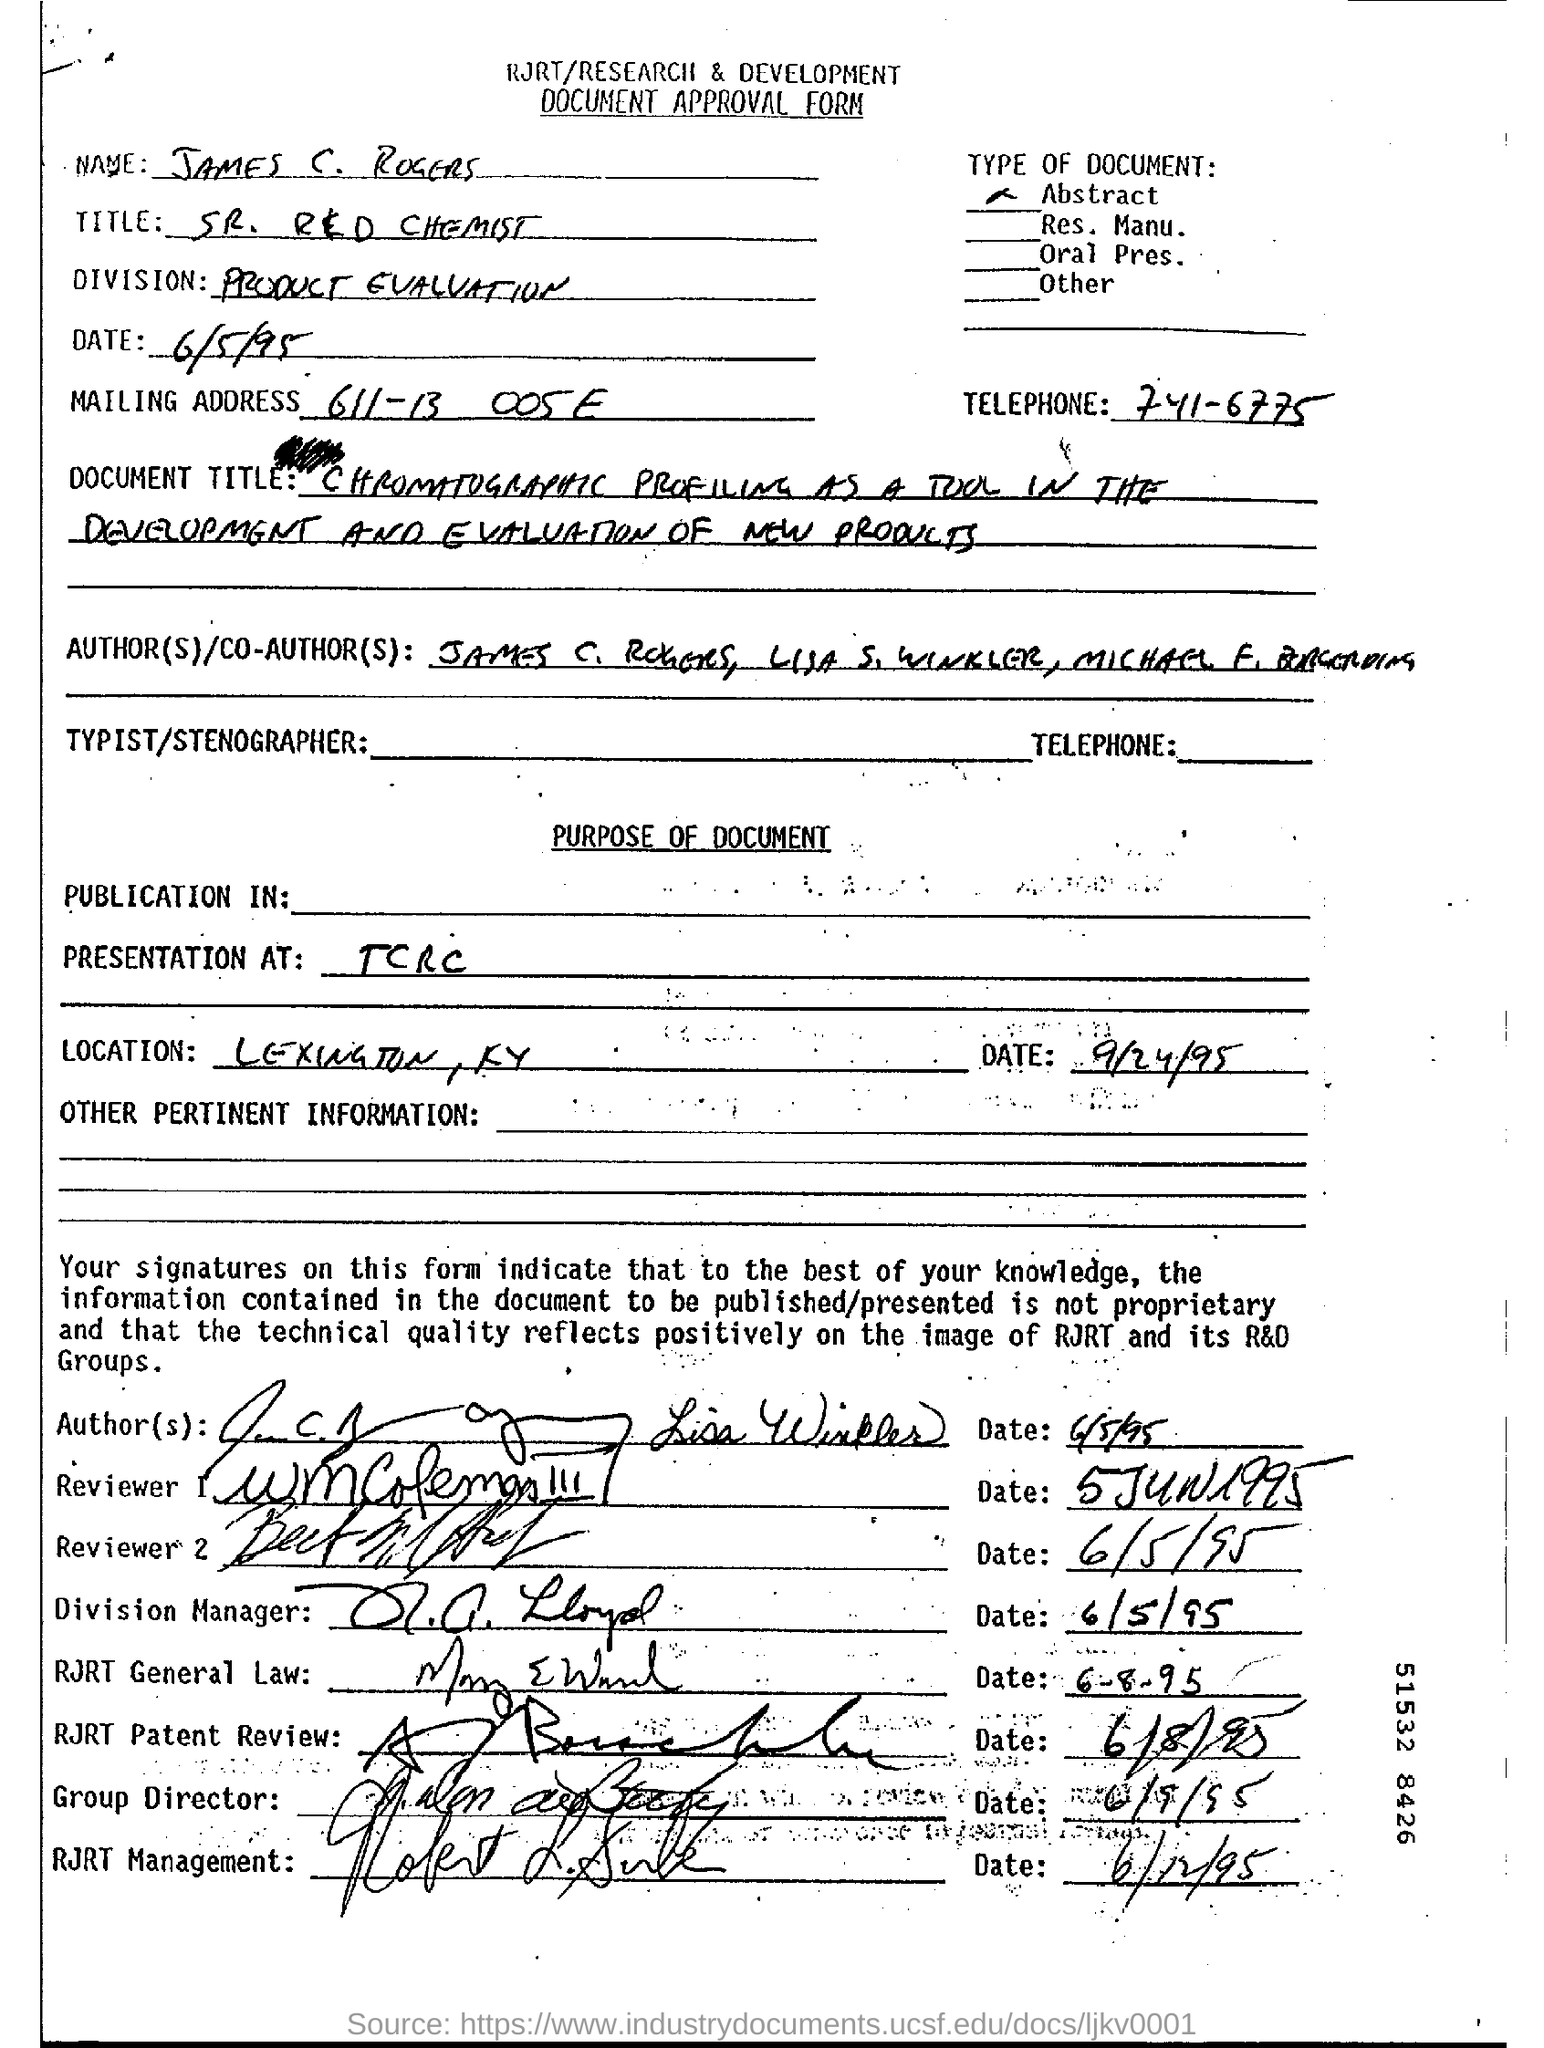What is the name of the person mentioned in the document?
Ensure brevity in your answer.  James C. Rogers. What is the division mentioned in the form?
Provide a succinct answer. PRODUCT EVALUATION. 